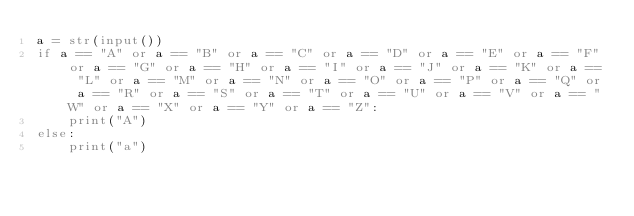<code> <loc_0><loc_0><loc_500><loc_500><_Python_>a = str(input())
if a == "A" or a == "B" or a == "C" or a == "D" or a == "E" or a == "F" or a == "G" or a == "H" or a == "I" or a == "J" or a == "K" or a == "L" or a == "M" or a == "N" or a == "O" or a == "P" or a == "Q" or a == "R" or a == "S" or a == "T" or a == "U" or a == "V" or a == "W" or a == "X" or a == "Y" or a == "Z":
    print("A")
else:
    print("a")</code> 